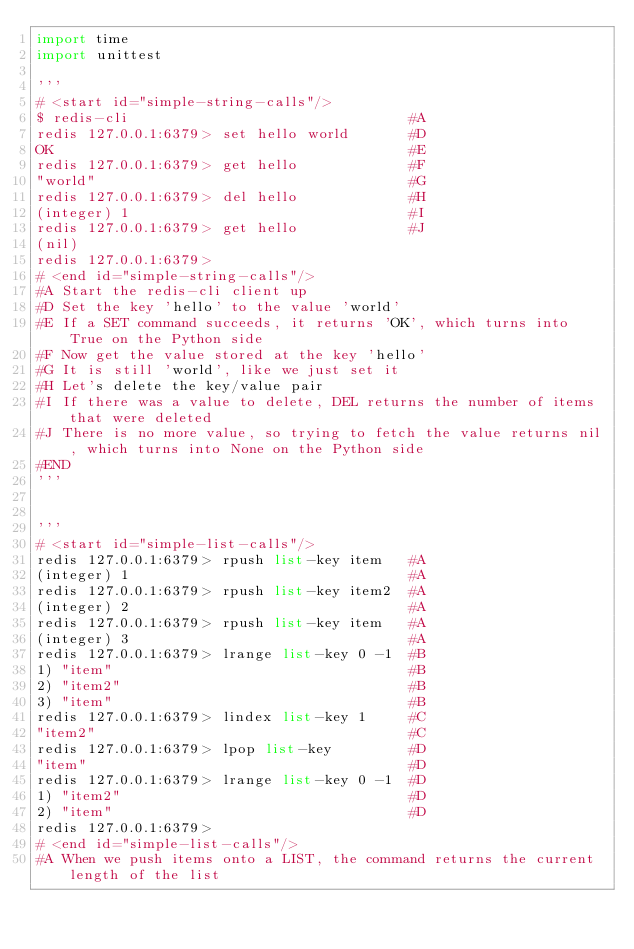<code> <loc_0><loc_0><loc_500><loc_500><_Python_>import time
import unittest

'''
# <start id="simple-string-calls"/>
$ redis-cli                                 #A
redis 127.0.0.1:6379> set hello world       #D
OK                                          #E
redis 127.0.0.1:6379> get hello             #F
"world"                                     #G
redis 127.0.0.1:6379> del hello             #H
(integer) 1                                 #I
redis 127.0.0.1:6379> get hello             #J
(nil)
redis 127.0.0.1:6379>
# <end id="simple-string-calls"/>
#A Start the redis-cli client up
#D Set the key 'hello' to the value 'world'
#E If a SET command succeeds, it returns 'OK', which turns into True on the Python side
#F Now get the value stored at the key 'hello'
#G It is still 'world', like we just set it
#H Let's delete the key/value pair
#I If there was a value to delete, DEL returns the number of items that were deleted
#J There is no more value, so trying to fetch the value returns nil, which turns into None on the Python side
#END
'''


'''
# <start id="simple-list-calls"/>
redis 127.0.0.1:6379> rpush list-key item   #A
(integer) 1                                 #A
redis 127.0.0.1:6379> rpush list-key item2  #A
(integer) 2                                 #A
redis 127.0.0.1:6379> rpush list-key item   #A
(integer) 3                                 #A
redis 127.0.0.1:6379> lrange list-key 0 -1  #B
1) "item"                                   #B
2) "item2"                                  #B
3) "item"                                   #B
redis 127.0.0.1:6379> lindex list-key 1     #C
"item2"                                     #C
redis 127.0.0.1:6379> lpop list-key         #D
"item"                                      #D
redis 127.0.0.1:6379> lrange list-key 0 -1  #D
1) "item2"                                  #D
2) "item"                                   #D
redis 127.0.0.1:6379>
# <end id="simple-list-calls"/>
#A When we push items onto a LIST, the command returns the current length of the list</code> 